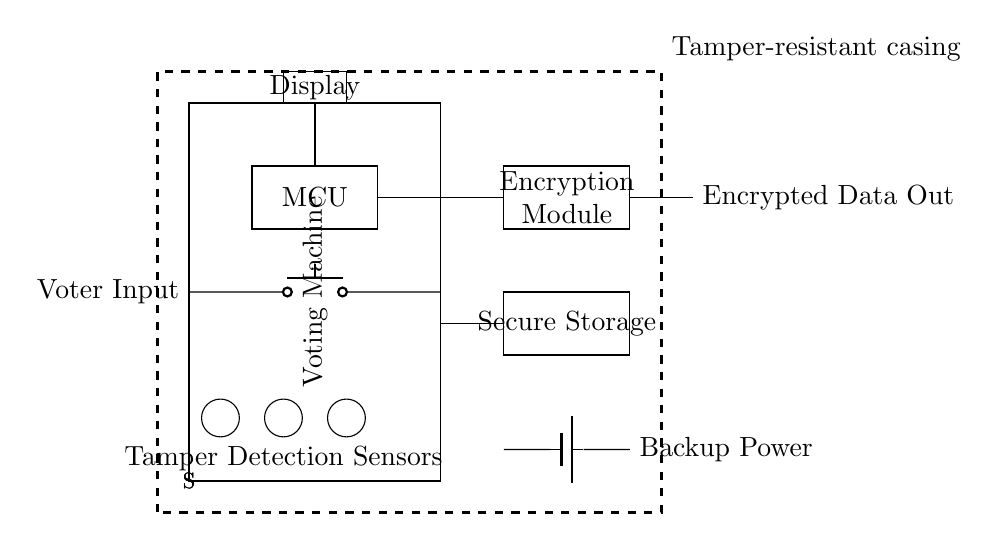What component is used for data encryption? The circuit diagram identifies the Encryption Module, which is specifically labeled, as the component responsible for data encryption.
Answer: Encryption Module What kind of sensors are present in the circuit? The circuit includes tamper detection sensors, indicated by the label "S" near a series of circles. These sensors are designed to detect unauthorized access or tampering.
Answer: Tamper Detection Sensors How is backup power supplied to the circuit? The circuit diagram shows a battery symbol connected to the circuit, indicating that backup power is supplied by a battery. This is critical for ensuring the machine remains operational during power outages.
Answer: Battery What is the function of the microcontroller in this circuit? The microcontroller (MCU) is responsible for processing inputs and controlling the other components in the circuit. It's the main processing unit and manages user interactions and data handling.
Answer: Processing Where does the encrypted data output go? The diagram shows an output labeled "Encrypted Data Out" connected to the Encryption Module, indicating that the output of this module is the encrypted data stream, meant for secure transmission.
Answer: Encrypted Data Out How does the tamper-resistant casing enhance security? The tamper-resistant casing, indicated by a dashed rectangle surrounding the entire circuit, significantly enhances security by providing a physical barrier against unauthorized access and tampering with the internal components.
Answer: Physical barrier What role does the display serve in the voting machine? The display is used to show information to the voter, such as options and confirmations. It is crucial for user interaction, ensuring that voters can view their selections before submission.
Answer: User interaction 